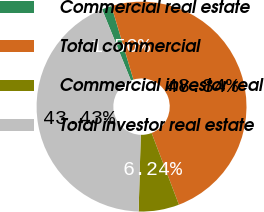Convert chart to OTSL. <chart><loc_0><loc_0><loc_500><loc_500><pie_chart><fcel>Commercial real estate<fcel>Total commercial<fcel>Commercial investor real<fcel>Total investor real estate<nl><fcel>1.5%<fcel>48.84%<fcel>6.24%<fcel>43.43%<nl></chart> 